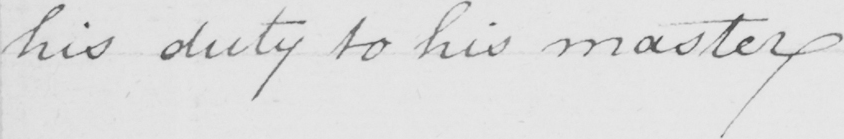Please transcribe the handwritten text in this image. his duty to his master . 